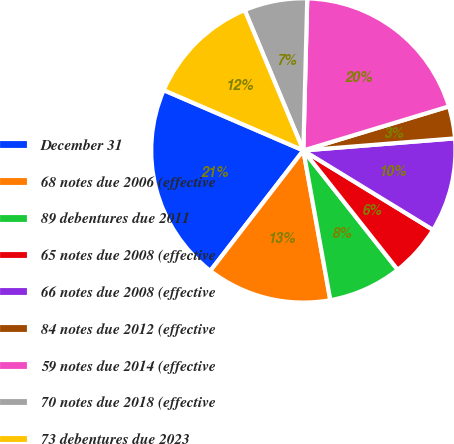<chart> <loc_0><loc_0><loc_500><loc_500><pie_chart><fcel>December 31<fcel>68 notes due 2006 (effective<fcel>89 debentures due 2011<fcel>65 notes due 2008 (effective<fcel>66 notes due 2008 (effective<fcel>84 notes due 2012 (effective<fcel>59 notes due 2014 (effective<fcel>70 notes due 2018 (effective<fcel>73 debentures due 2023<nl><fcel>21.02%<fcel>13.31%<fcel>7.81%<fcel>5.61%<fcel>10.01%<fcel>3.41%<fcel>19.92%<fcel>6.71%<fcel>12.21%<nl></chart> 